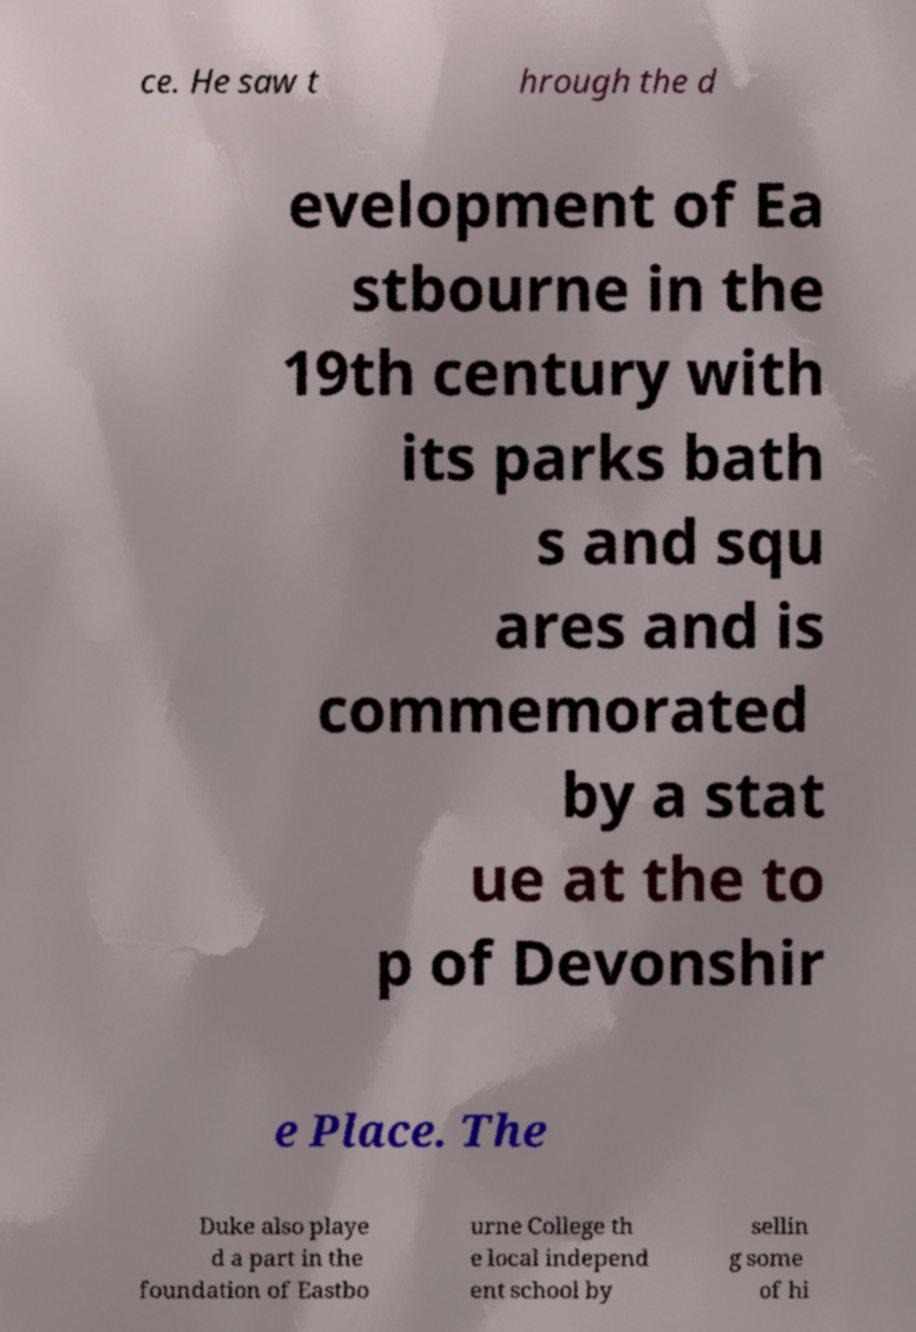Please identify and transcribe the text found in this image. ce. He saw t hrough the d evelopment of Ea stbourne in the 19th century with its parks bath s and squ ares and is commemorated by a stat ue at the to p of Devonshir e Place. The Duke also playe d a part in the foundation of Eastbo urne College th e local independ ent school by sellin g some of hi 